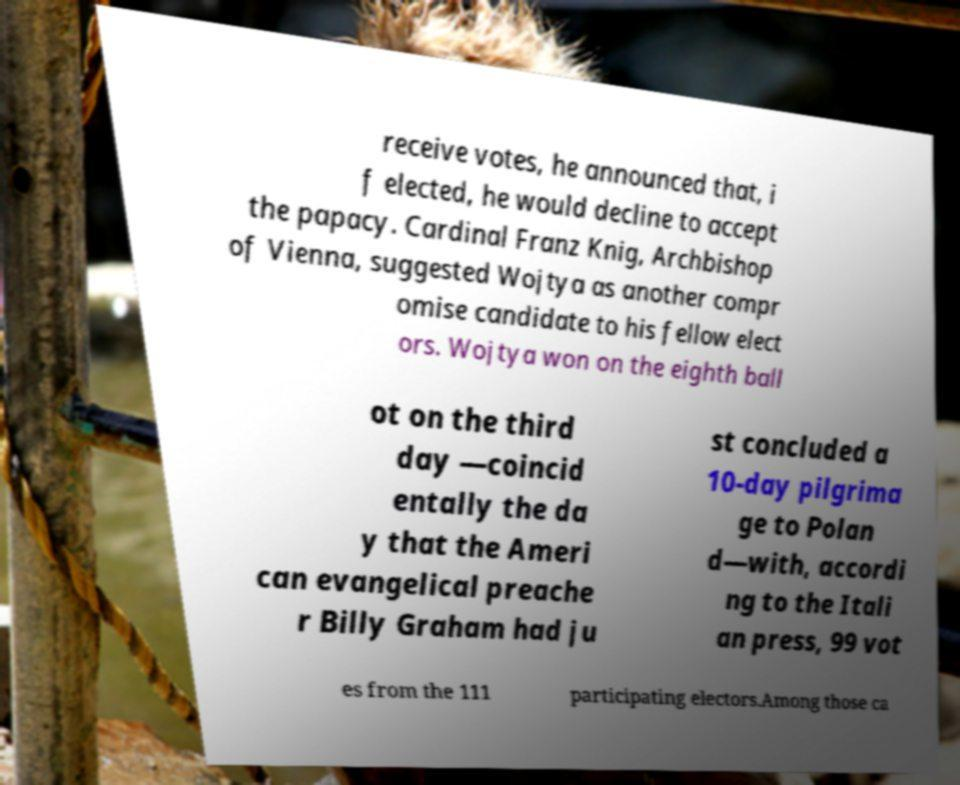For documentation purposes, I need the text within this image transcribed. Could you provide that? receive votes, he announced that, i f elected, he would decline to accept the papacy. Cardinal Franz Knig, Archbishop of Vienna, suggested Wojtya as another compr omise candidate to his fellow elect ors. Wojtya won on the eighth ball ot on the third day —coincid entally the da y that the Ameri can evangelical preache r Billy Graham had ju st concluded a 10-day pilgrima ge to Polan d—with, accordi ng to the Itali an press, 99 vot es from the 111 participating electors.Among those ca 